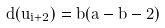Convert formula to latex. <formula><loc_0><loc_0><loc_500><loc_500>d ( u _ { i + 2 } ) = b ( a - b - 2 )</formula> 